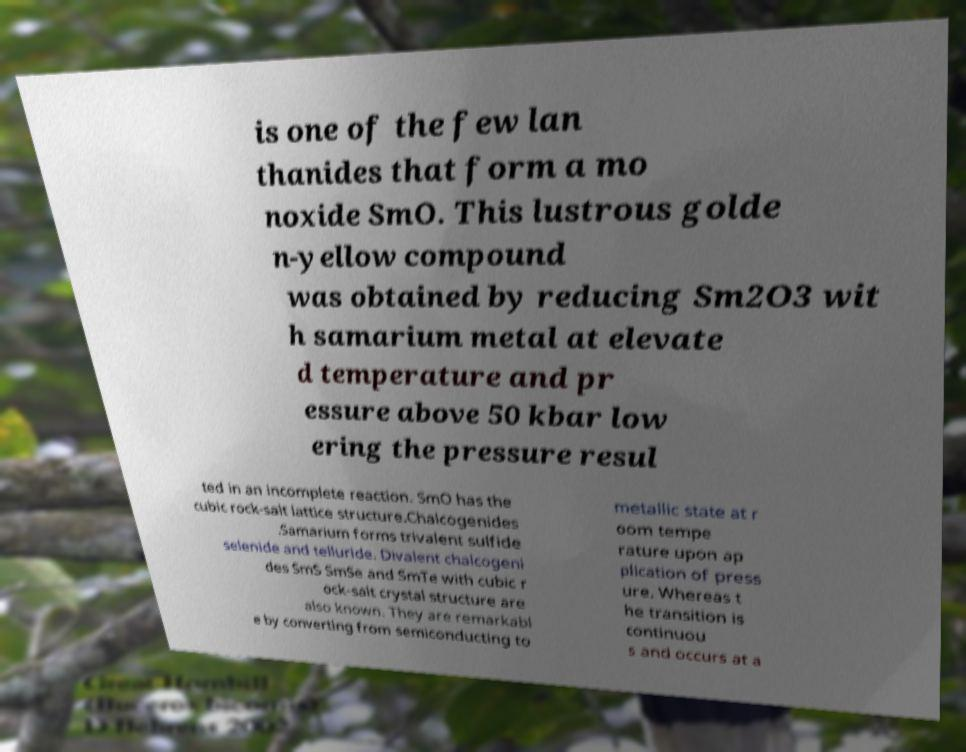Can you read and provide the text displayed in the image?This photo seems to have some interesting text. Can you extract and type it out for me? is one of the few lan thanides that form a mo noxide SmO. This lustrous golde n-yellow compound was obtained by reducing Sm2O3 wit h samarium metal at elevate d temperature and pr essure above 50 kbar low ering the pressure resul ted in an incomplete reaction. SmO has the cubic rock-salt lattice structure.Chalcogenides .Samarium forms trivalent sulfide selenide and telluride. Divalent chalcogeni des SmS SmSe and SmTe with cubic r ock-salt crystal structure are also known. They are remarkabl e by converting from semiconducting to metallic state at r oom tempe rature upon ap plication of press ure. Whereas t he transition is continuou s and occurs at a 